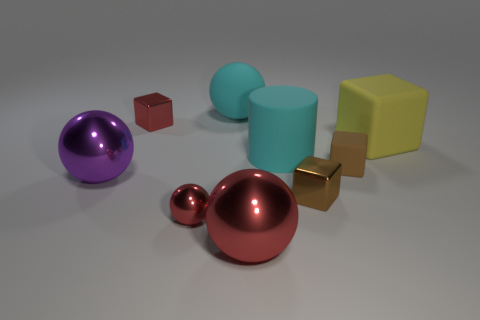Add 1 large yellow matte blocks. How many objects exist? 10 Subtract all cylinders. How many objects are left? 8 Add 2 large blocks. How many large blocks are left? 3 Add 3 big yellow matte cylinders. How many big yellow matte cylinders exist? 3 Subtract 1 purple spheres. How many objects are left? 8 Subtract all big cyan rubber objects. Subtract all brown things. How many objects are left? 5 